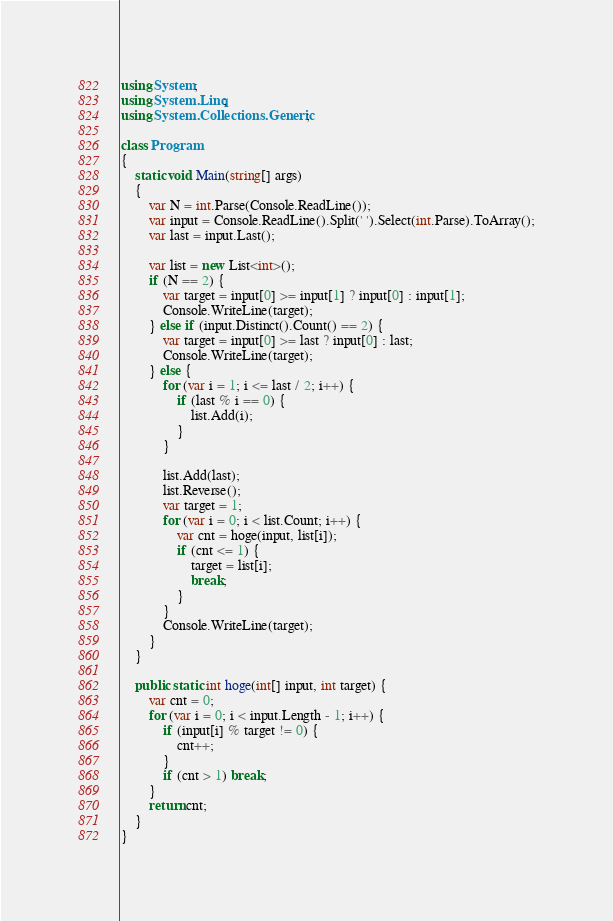<code> <loc_0><loc_0><loc_500><loc_500><_C#_>using System;
using System.Linq;
using System.Collections.Generic;

class Program
{
    static void Main(string[] args)
    {
        var N = int.Parse(Console.ReadLine());
        var input = Console.ReadLine().Split(' ').Select(int.Parse).ToArray();
        var last = input.Last();
        
        var list = new List<int>();
        if (N == 2) {
            var target = input[0] >= input[1] ? input[0] : input[1];
            Console.WriteLine(target);
        } else if (input.Distinct().Count() == 2) {
            var target = input[0] >= last ? input[0] : last;
            Console.WriteLine(target);
        } else {
            for (var i = 1; i <= last / 2; i++) {
                if (last % i == 0) {
                    list.Add(i);
                }
            }
            
            list.Add(last);
            list.Reverse();
            var target = 1;
            for (var i = 0; i < list.Count; i++) {
                var cnt = hoge(input, list[i]);
                if (cnt <= 1) {
                    target = list[i];
                    break;
                }
            }            
            Console.WriteLine(target);
        }
    }
    
    public static int hoge(int[] input, int target) {
        var cnt = 0;
        for (var i = 0; i < input.Length - 1; i++) {
            if (input[i] % target != 0) {
                cnt++;
            }
            if (cnt > 1) break;
        }
        return cnt;
    }
}
</code> 